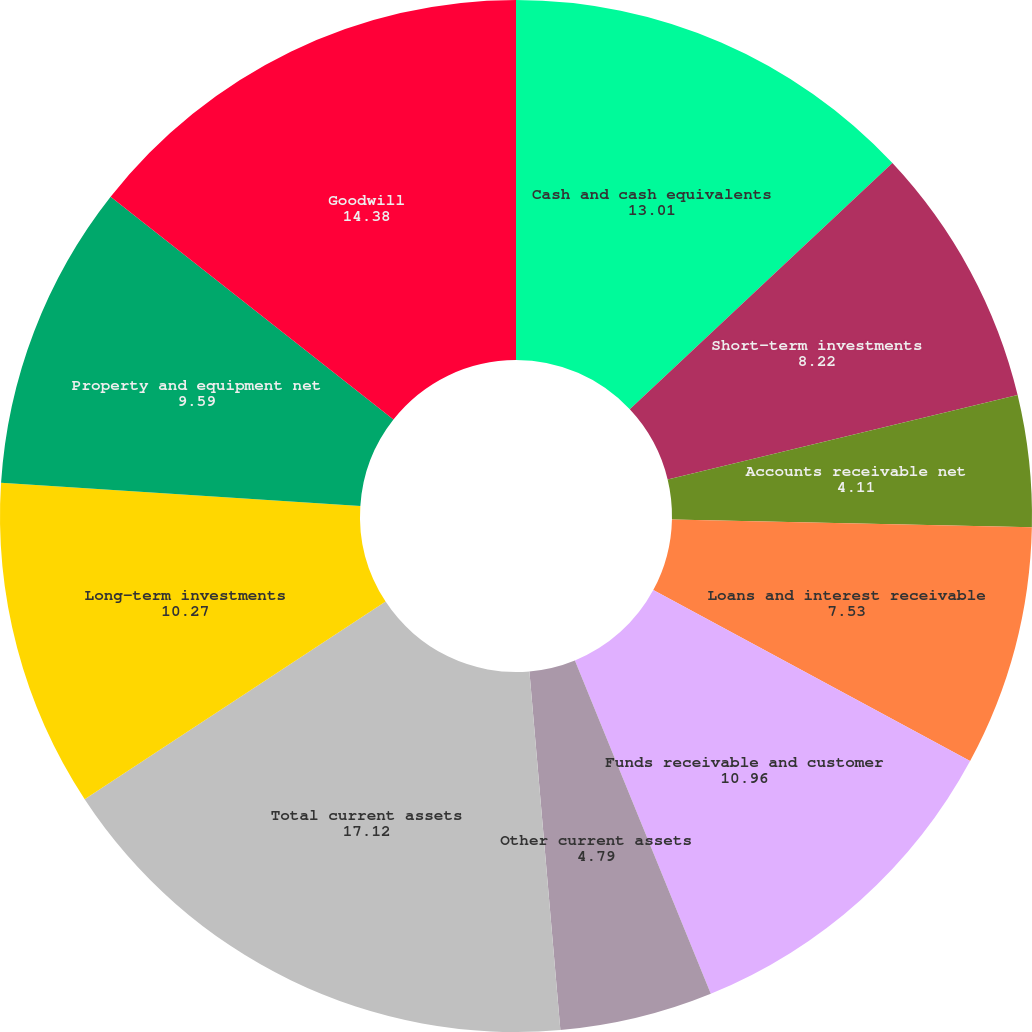<chart> <loc_0><loc_0><loc_500><loc_500><pie_chart><fcel>Cash and cash equivalents<fcel>Short-term investments<fcel>Accounts receivable net<fcel>Loans and interest receivable<fcel>Funds receivable and customer<fcel>Other current assets<fcel>Total current assets<fcel>Long-term investments<fcel>Property and equipment net<fcel>Goodwill<nl><fcel>13.01%<fcel>8.22%<fcel>4.11%<fcel>7.53%<fcel>10.96%<fcel>4.79%<fcel>17.12%<fcel>10.27%<fcel>9.59%<fcel>14.38%<nl></chart> 